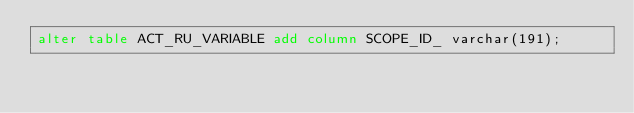<code> <loc_0><loc_0><loc_500><loc_500><_SQL_>alter table ACT_RU_VARIABLE add column SCOPE_ID_ varchar(191);</code> 